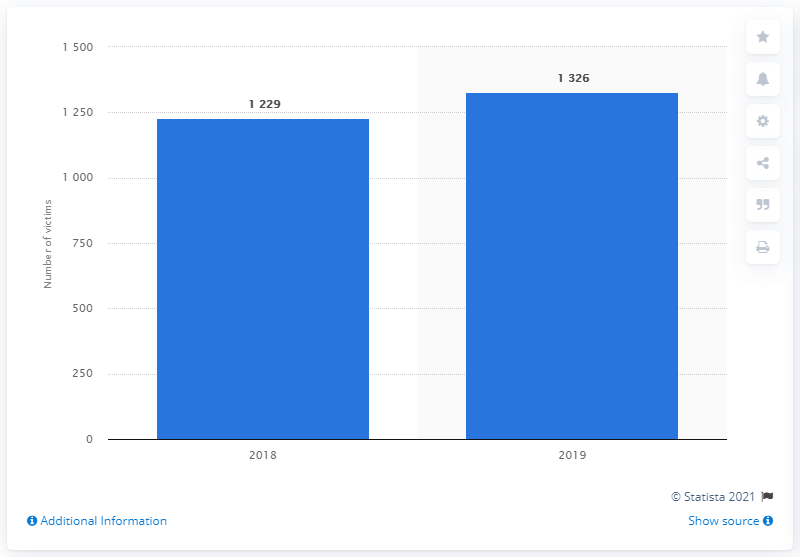Highlight a few significant elements in this photo. According to data, Brazil's femicide rate has remained stable since 2018. 